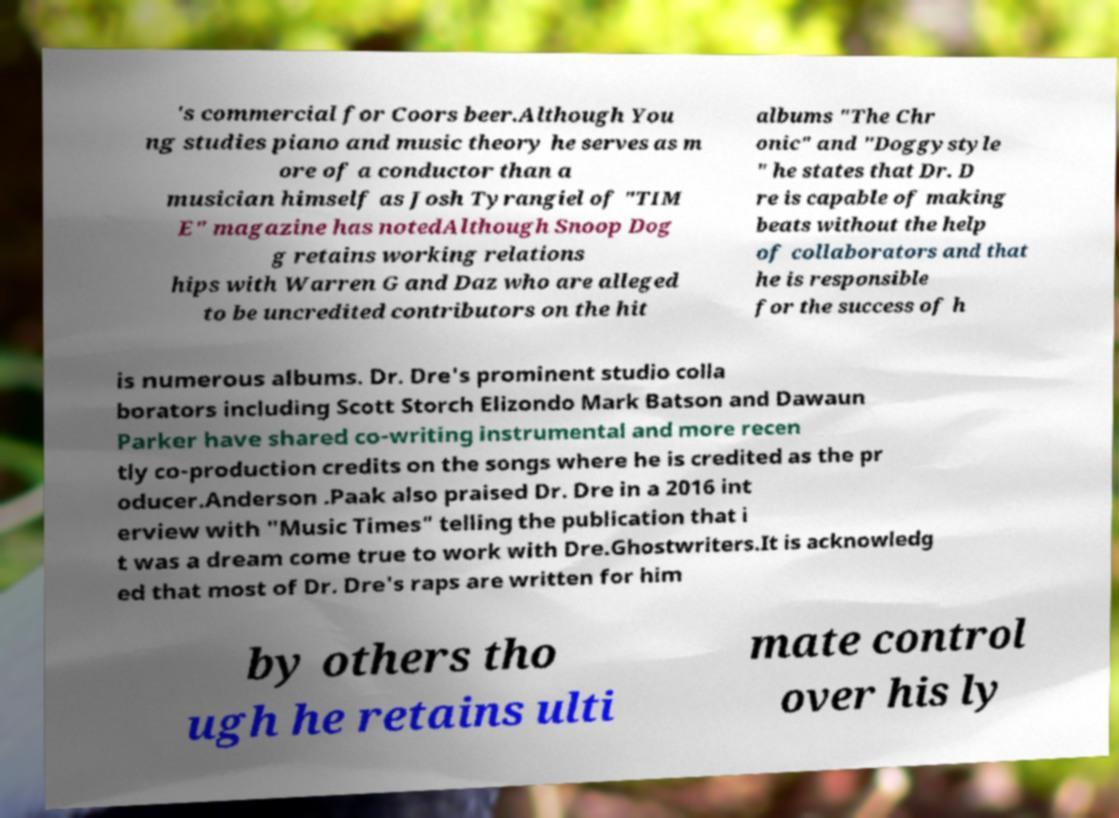Could you extract and type out the text from this image? 's commercial for Coors beer.Although You ng studies piano and music theory he serves as m ore of a conductor than a musician himself as Josh Tyrangiel of "TIM E" magazine has notedAlthough Snoop Dog g retains working relations hips with Warren G and Daz who are alleged to be uncredited contributors on the hit albums "The Chr onic" and "Doggystyle " he states that Dr. D re is capable of making beats without the help of collaborators and that he is responsible for the success of h is numerous albums. Dr. Dre's prominent studio colla borators including Scott Storch Elizondo Mark Batson and Dawaun Parker have shared co-writing instrumental and more recen tly co-production credits on the songs where he is credited as the pr oducer.Anderson .Paak also praised Dr. Dre in a 2016 int erview with "Music Times" telling the publication that i t was a dream come true to work with Dre.Ghostwriters.It is acknowledg ed that most of Dr. Dre's raps are written for him by others tho ugh he retains ulti mate control over his ly 